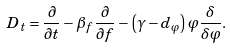<formula> <loc_0><loc_0><loc_500><loc_500>D _ { t } = \frac { \partial } { \partial t } - \beta _ { f } \frac { \partial } { \partial f } - \left ( \gamma - d _ { \varphi } \right ) \varphi \frac { \delta } { \delta \varphi } .</formula> 